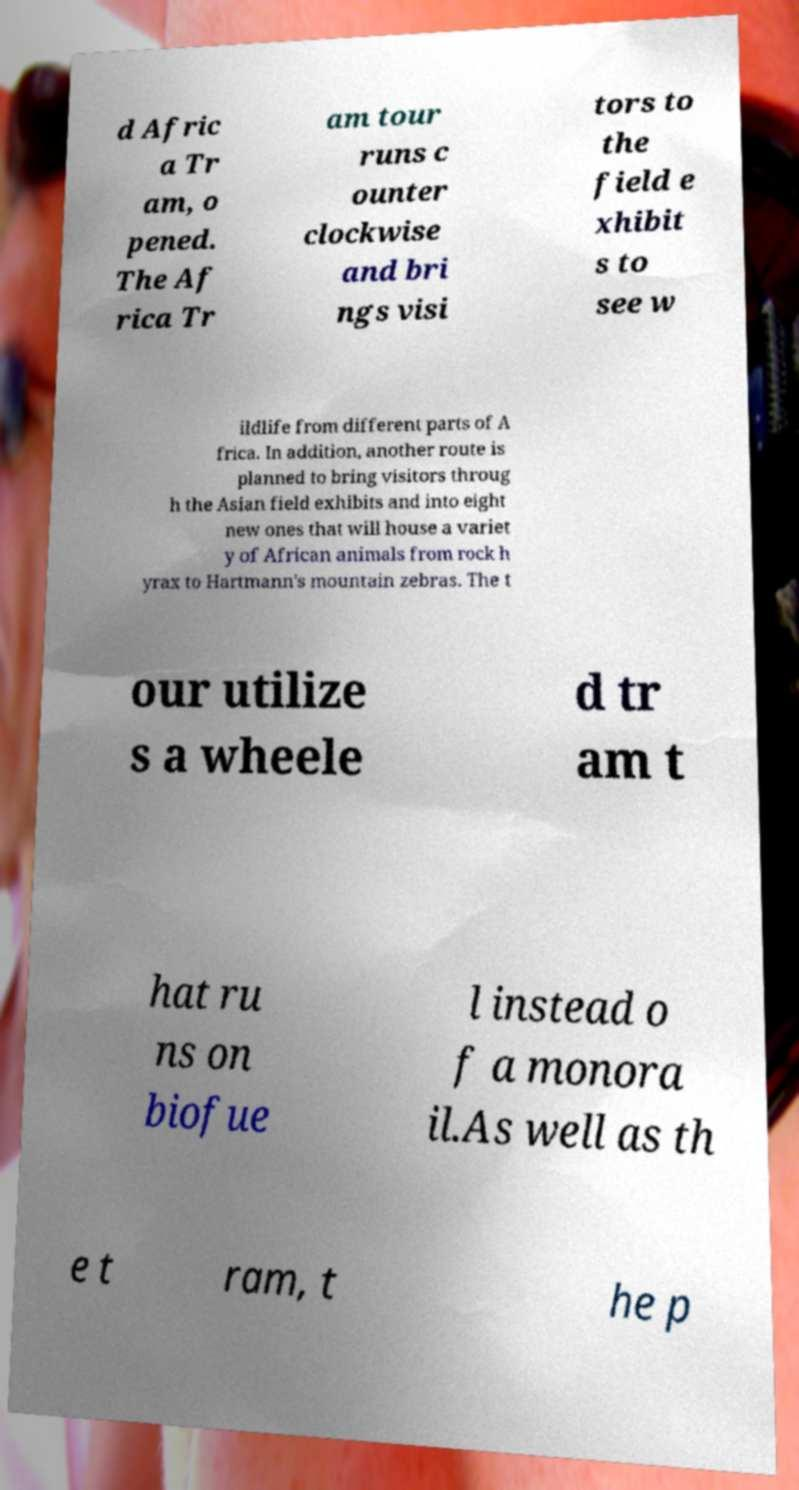Please identify and transcribe the text found in this image. d Afric a Tr am, o pened. The Af rica Tr am tour runs c ounter clockwise and bri ngs visi tors to the field e xhibit s to see w ildlife from different parts of A frica. In addition, another route is planned to bring visitors throug h the Asian field exhibits and into eight new ones that will house a variet y of African animals from rock h yrax to Hartmann's mountain zebras. The t our utilize s a wheele d tr am t hat ru ns on biofue l instead o f a monora il.As well as th e t ram, t he p 